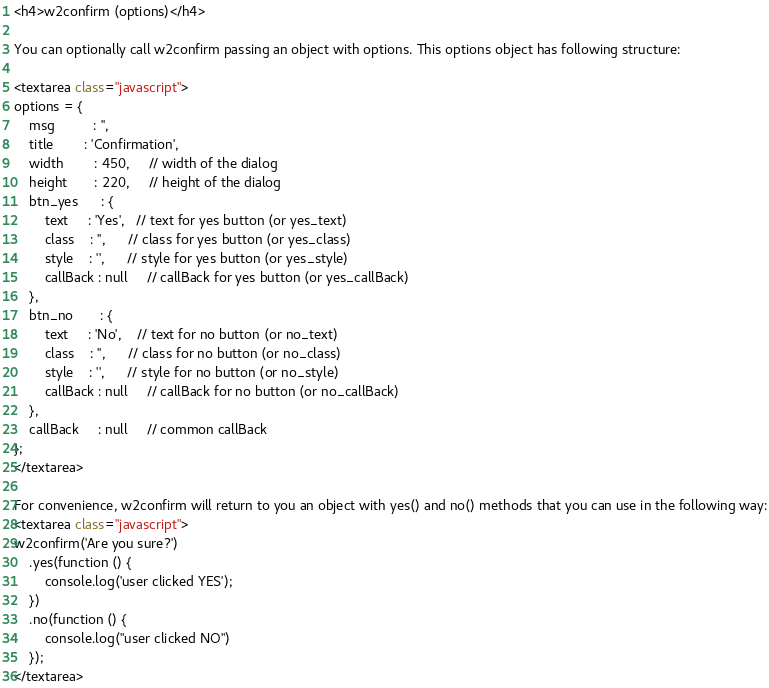<code> <loc_0><loc_0><loc_500><loc_500><_HTML_><h4>w2confirm (options)</h4>

You can optionally call w2confirm passing an object with options. This options object has following structure:

<textarea class="javascript">
options = {
    msg          : '',
    title        : 'Confirmation',
    width        : 450,     // width of the dialog
    height       : 220,     // height of the dialog
    btn_yes      : {
        text     : 'Yes',   // text for yes button (or yes_text)
        class    : '',      // class for yes button (or yes_class)
        style    : '',      // style for yes button (or yes_style)
        callBack : null     // callBack for yes button (or yes_callBack)
    },
    btn_no       : {
        text     : 'No',    // text for no button (or no_text)
        class    : '',      // class for no button (or no_class)
        style    : '',      // style for no button (or no_style)
        callBack : null     // callBack for no button (or no_callBack)
    },
    callBack     : null     // common callBack
};
</textarea>

For convenience, w2confirm will return to you an object with yes() and no() methods that you can use in the following way:
<textarea class="javascript">
w2confirm('Are you sure?')
    .yes(function () {
        console.log('user clicked YES');
    })
    .no(function () {
        console.log("user clicked NO")
    });
</textarea>
</code> 